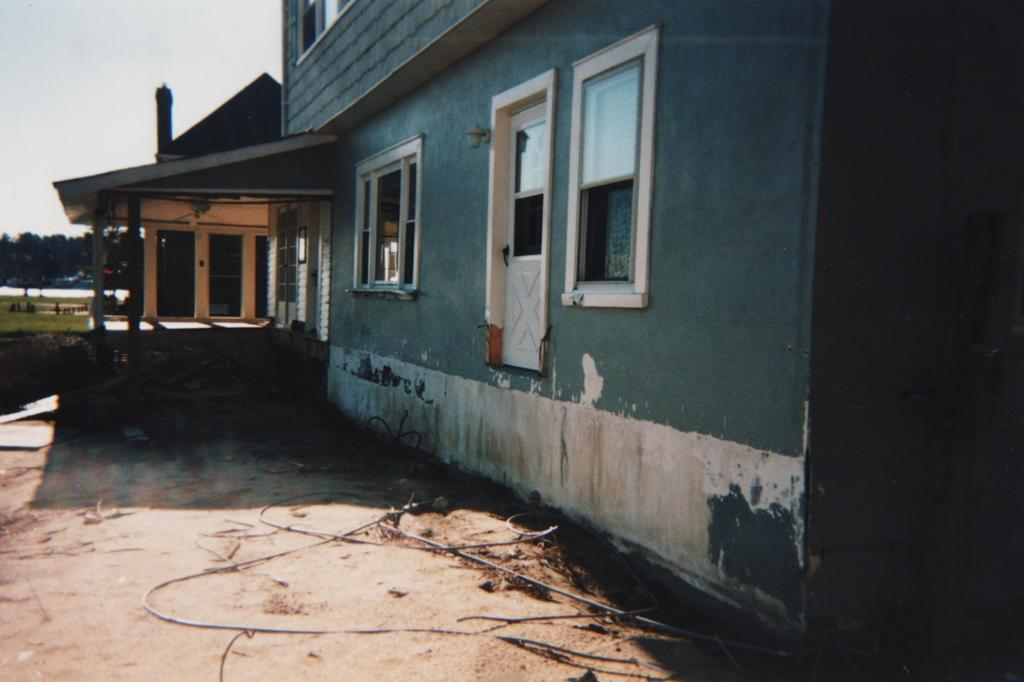What type of structure is present in the image? There is a building in the image. What can be seen on the left side of the image? There is a grassland with plants on the left side of the image. Are there any trees visible in the image? Yes, there are trees on the land in the image. What part of the sky is visible in the image? The sky is visible at the left top of the image. What type of cloth is draped over the chair in the image? There is no chair or cloth present in the image. 